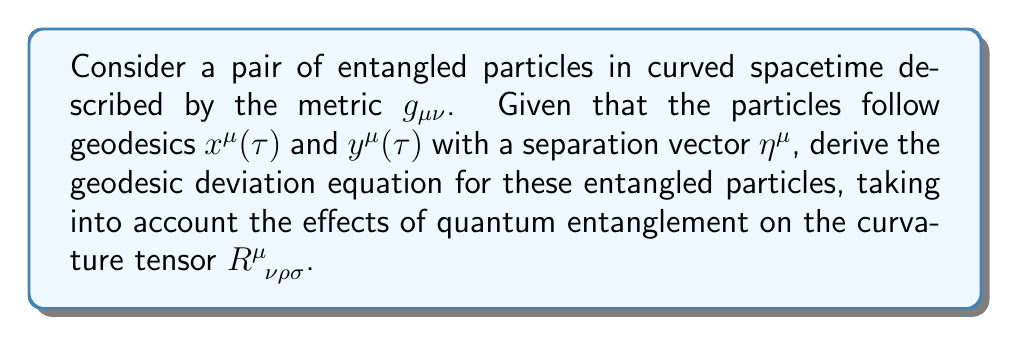Give your solution to this math problem. To derive the geodesic deviation equation for entangled particles in curved spacetime, we'll follow these steps:

1. Start with the classical geodesic deviation equation:
   $$\frac{D^2\eta^{\mu}}{D\tau^2} + R^{\mu}_{\;\;\nu\rho\sigma}u^{\nu}\eta^{\rho}u^{\sigma} = 0$$
   where $u^{\mu} = \frac{dx^{\mu}}{d\tau}$ is the four-velocity.

2. Consider the quantum entanglement effect on the curvature tensor. We introduce a quantum correction term $Q^{\mu}_{\;\;\nu\rho\sigma}$ to the classical Riemann tensor:
   $$R^{\mu}_{\;\;\nu\rho\sigma} \rightarrow R^{\mu}_{\;\;\nu\rho\sigma} + Q^{\mu}_{\;\;\nu\rho\sigma}$$

3. The quantum correction term $Q^{\mu}_{\;\;\nu\rho\sigma}$ can be expressed as a function of the entanglement entropy $S_E$:
   $$Q^{\mu}_{\;\;\nu\rho\sigma} = \alpha \frac{\partial^2 S_E}{\partial x^{\mu}\partial x^{\nu}} g_{\rho\sigma}$$
   where $\alpha$ is a coupling constant.

4. Substitute the modified curvature tensor into the geodesic deviation equation:
   $$\frac{D^2\eta^{\mu}}{D\tau^2} + (R^{\mu}_{\;\;\nu\rho\sigma} + Q^{\mu}_{\;\;\nu\rho\sigma})u^{\nu}\eta^{\rho}u^{\sigma} = 0$$

5. Expand the equation:
   $$\frac{D^2\eta^{\mu}}{D\tau^2} + R^{\mu}_{\;\;\nu\rho\sigma}u^{\nu}\eta^{\rho}u^{\sigma} + \alpha \frac{\partial^2 S_E}{\partial x^{\mu}\partial x^{\nu}} g_{\rho\sigma}u^{\nu}\eta^{\rho}u^{\sigma} = 0$$

6. Simplify by defining $\Omega^{\mu} = \alpha \frac{\partial^2 S_E}{\partial x^{\mu}\partial x^{\nu}} g_{\rho\sigma}u^{\nu}\eta^{\rho}u^{\sigma}$:
   $$\frac{D^2\eta^{\mu}}{D\tau^2} + R^{\mu}_{\;\;\nu\rho\sigma}u^{\nu}\eta^{\rho}u^{\sigma} + \Omega^{\mu} = 0$$

This is the geodesic deviation equation for entangled particles in curved spacetime, taking into account the quantum entanglement effects on the curvature tensor.
Answer: $$\frac{D^2\eta^{\mu}}{D\tau^2} + R^{\mu}_{\;\;\nu\rho\sigma}u^{\nu}\eta^{\rho}u^{\sigma} + \Omega^{\mu} = 0$$
where $\Omega^{\mu} = \alpha \frac{\partial^2 S_E}{\partial x^{\mu}\partial x^{\nu}} g_{\rho\sigma}u^{\nu}\eta^{\rho}u^{\sigma}$ 